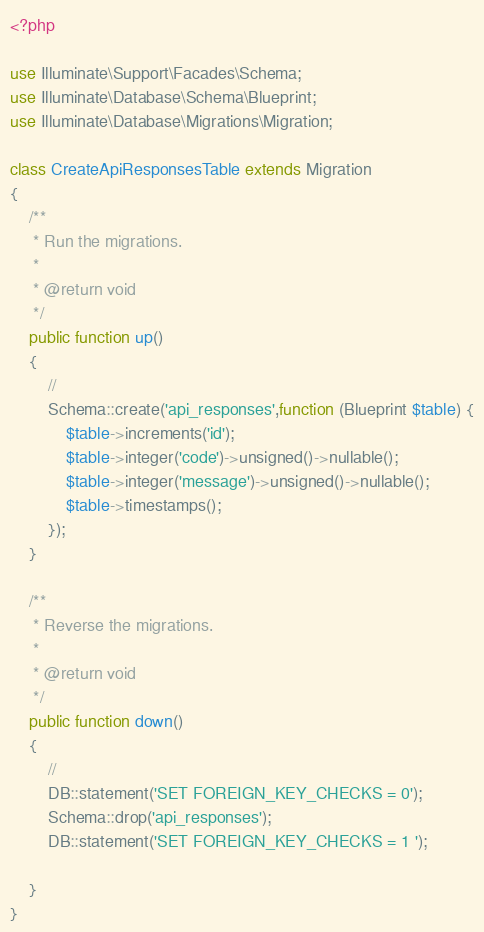Convert code to text. <code><loc_0><loc_0><loc_500><loc_500><_PHP_><?php

use Illuminate\Support\Facades\Schema;
use Illuminate\Database\Schema\Blueprint;
use Illuminate\Database\Migrations\Migration;

class CreateApiResponsesTable extends Migration
{
    /**
     * Run the migrations.
     *
     * @return void
     */
    public function up()
    {
        //
        Schema::create('api_responses',function (Blueprint $table) {
            $table->increments('id');
            $table->integer('code')->unsigned()->nullable();
            $table->integer('message')->unsigned()->nullable();
            $table->timestamps();
        });
    }

    /**
     * Reverse the migrations.
     *
     * @return void
     */
    public function down()
    {
        //
        DB::statement('SET FOREIGN_KEY_CHECKS = 0');
        Schema::drop('api_responses');
        DB::statement('SET FOREIGN_KEY_CHECKS = 1 ');

    }
}
</code> 